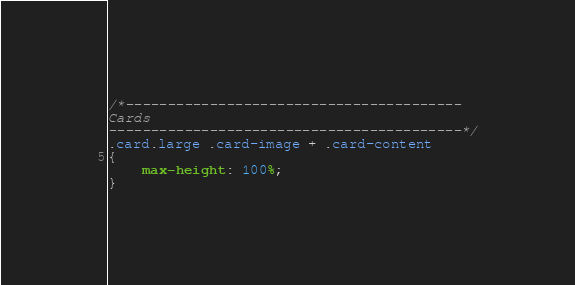<code> <loc_0><loc_0><loc_500><loc_500><_CSS_>/*----------------------------------------
Cards
------------------------------------------*/
.card.large .card-image + .card-content
{
    max-height: 100%;
}
</code> 